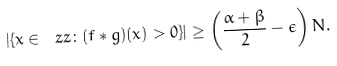Convert formula to latex. <formula><loc_0><loc_0><loc_500><loc_500>| \{ x \in \ z z \colon ( f \ast g ) ( x ) > 0 \} | \geq \left ( \frac { \alpha + \beta } { 2 } - \epsilon \right ) N .</formula> 